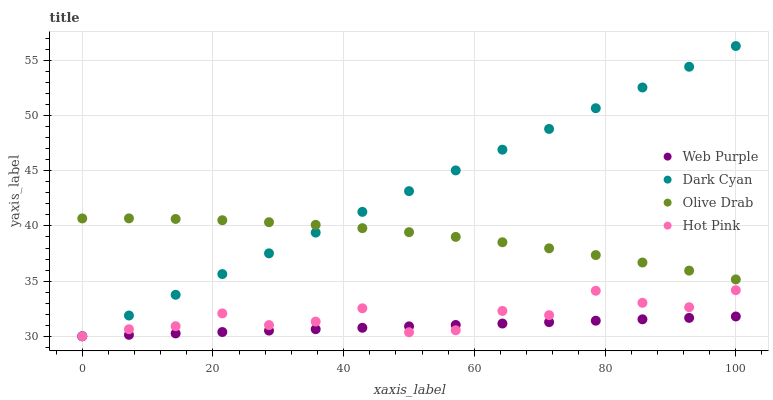Does Web Purple have the minimum area under the curve?
Answer yes or no. Yes. Does Dark Cyan have the maximum area under the curve?
Answer yes or no. Yes. Does Hot Pink have the minimum area under the curve?
Answer yes or no. No. Does Hot Pink have the maximum area under the curve?
Answer yes or no. No. Is Dark Cyan the smoothest?
Answer yes or no. Yes. Is Hot Pink the roughest?
Answer yes or no. Yes. Is Web Purple the smoothest?
Answer yes or no. No. Is Web Purple the roughest?
Answer yes or no. No. Does Dark Cyan have the lowest value?
Answer yes or no. Yes. Does Olive Drab have the lowest value?
Answer yes or no. No. Does Dark Cyan have the highest value?
Answer yes or no. Yes. Does Hot Pink have the highest value?
Answer yes or no. No. Is Web Purple less than Olive Drab?
Answer yes or no. Yes. Is Olive Drab greater than Web Purple?
Answer yes or no. Yes. Does Dark Cyan intersect Olive Drab?
Answer yes or no. Yes. Is Dark Cyan less than Olive Drab?
Answer yes or no. No. Is Dark Cyan greater than Olive Drab?
Answer yes or no. No. Does Web Purple intersect Olive Drab?
Answer yes or no. No. 